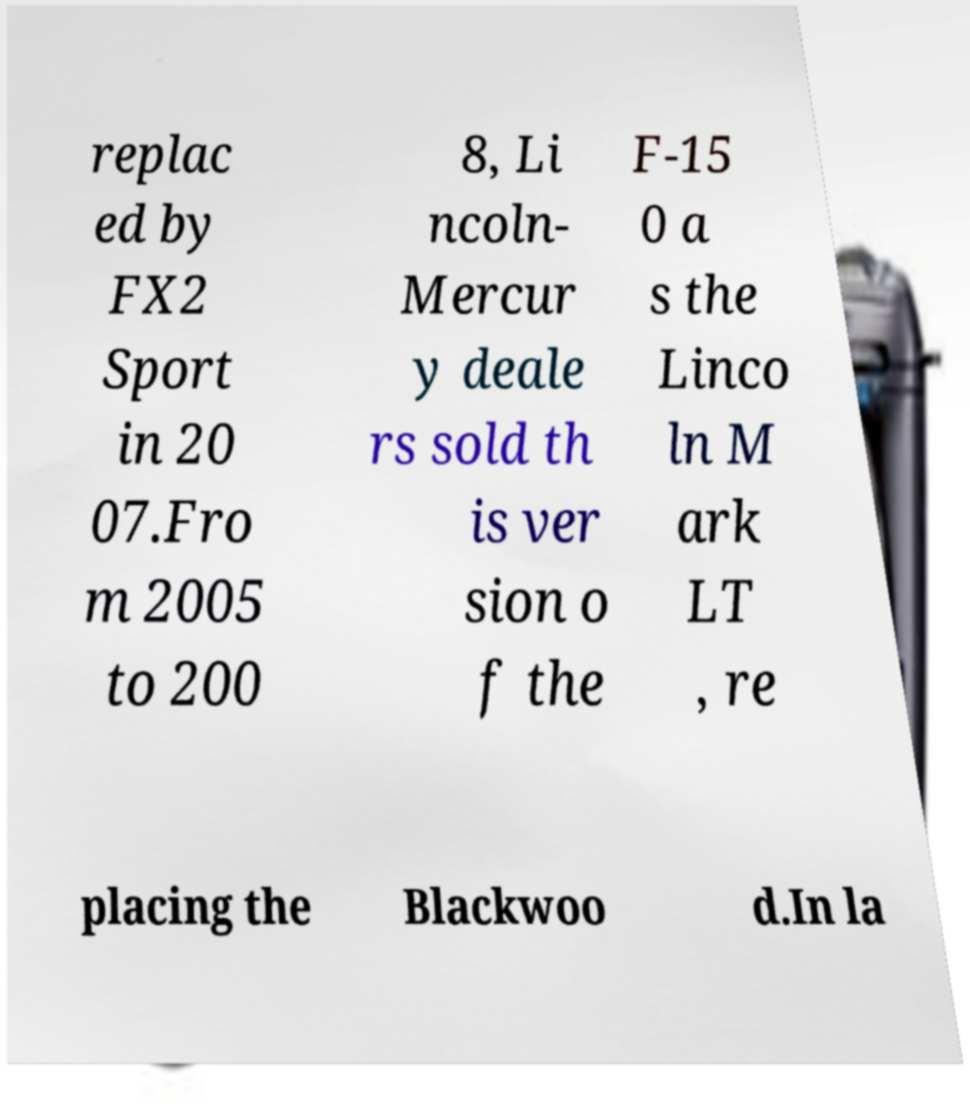Could you assist in decoding the text presented in this image and type it out clearly? replac ed by FX2 Sport in 20 07.Fro m 2005 to 200 8, Li ncoln- Mercur y deale rs sold th is ver sion o f the F-15 0 a s the Linco ln M ark LT , re placing the Blackwoo d.In la 